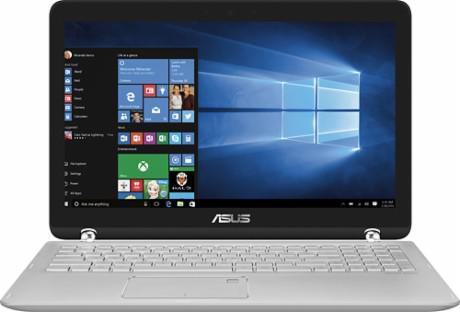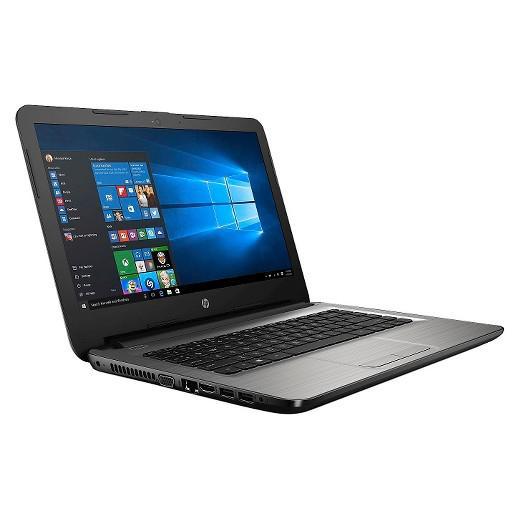The first image is the image on the left, the second image is the image on the right. For the images displayed, is the sentence "One of the images contains a laptop turned toward the right." factually correct? Answer yes or no. Yes. 